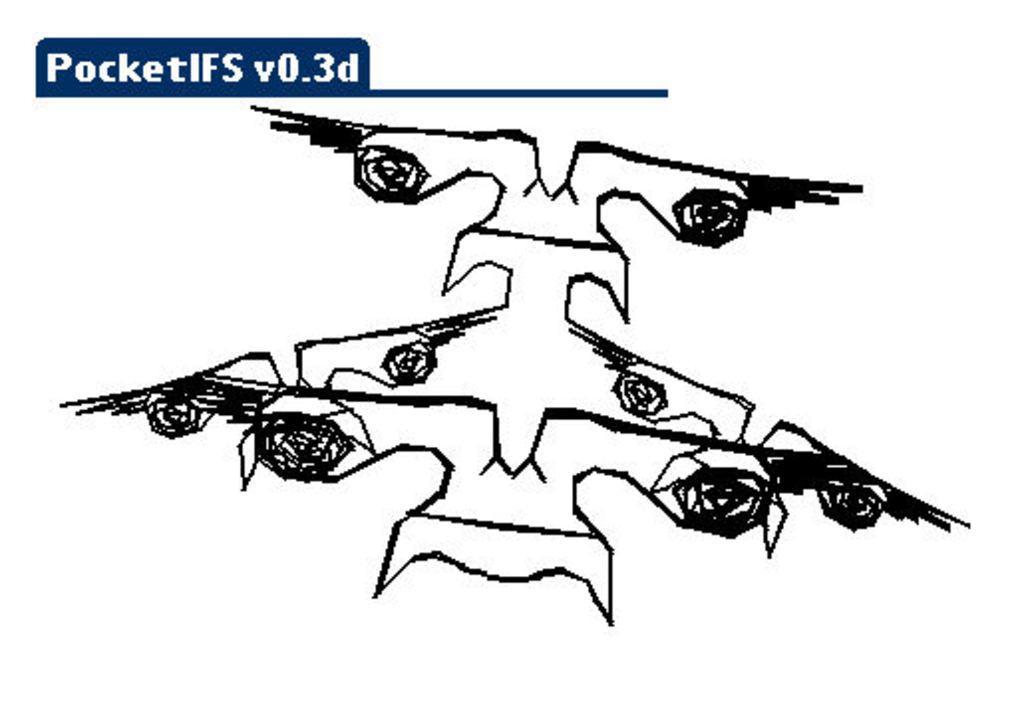Can you describe this image briefly? The picture consists of a drawing. At the top there is text. 